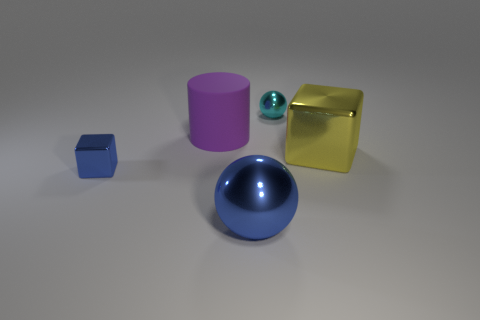Add 2 matte things. How many objects exist? 7 Subtract all cylinders. How many objects are left? 4 Add 2 big purple objects. How many big purple objects are left? 3 Add 1 large cyan metallic blocks. How many large cyan metallic blocks exist? 1 Subtract 0 yellow balls. How many objects are left? 5 Subtract all rubber cylinders. Subtract all purple cylinders. How many objects are left? 3 